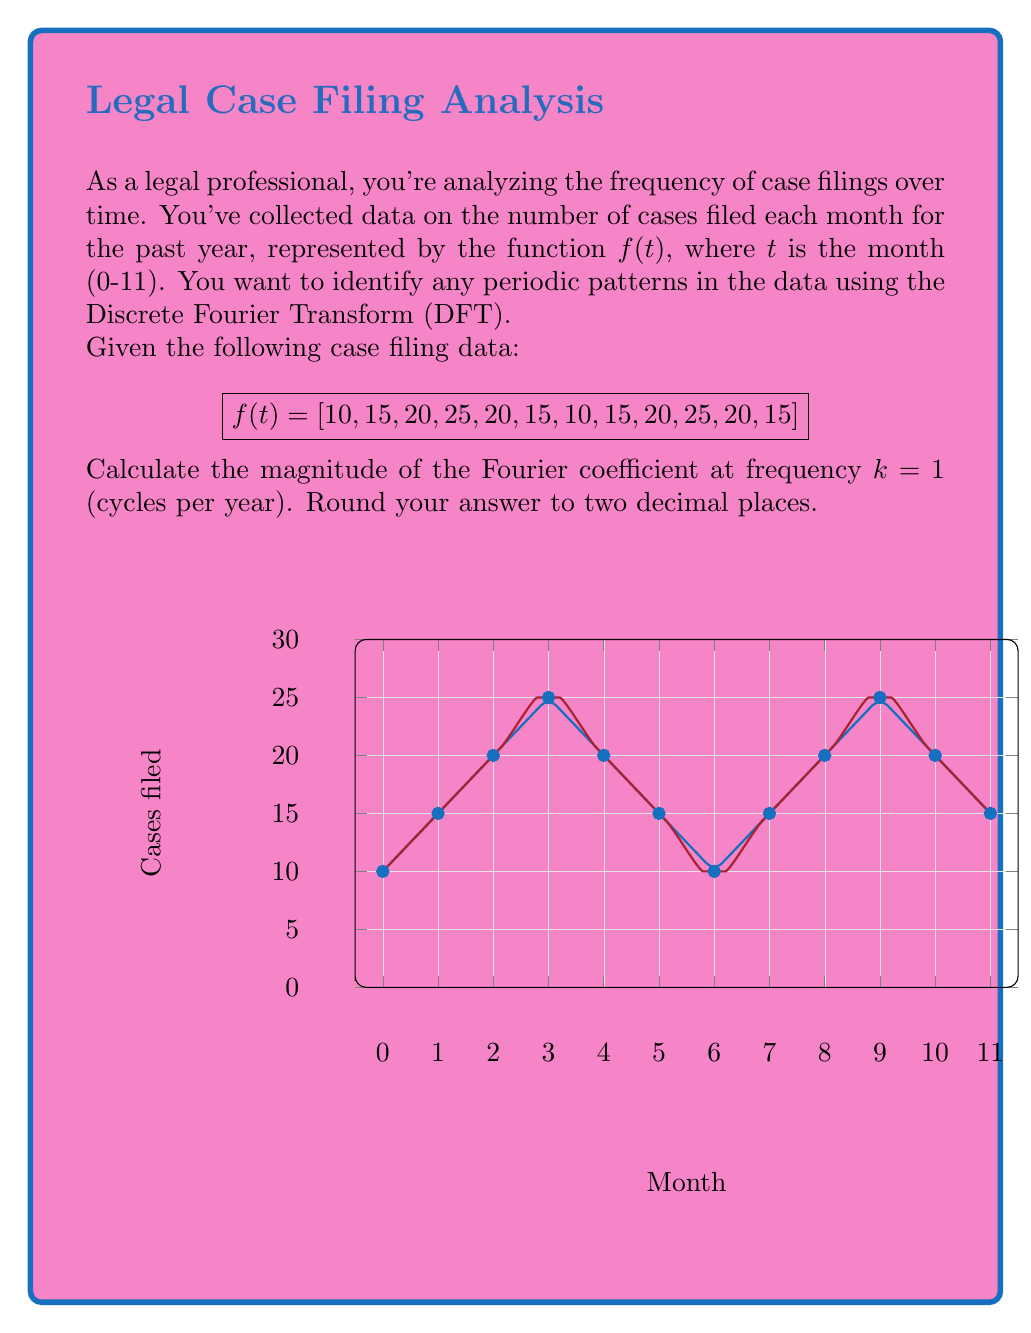Can you solve this math problem? To solve this problem, we'll follow these steps:

1) The Discrete Fourier Transform (DFT) for a sequence of N points is given by:

   $$X_k = \sum_{n=0}^{N-1} x_n e^{-i2\pi kn/N}$$

   where $X_k$ is the k-th Fourier coefficient, $x_n$ is the n-th input sample, and N is the total number of samples.

2) In this case, N = 12 (12 months of data), and we're asked to calculate for k = 1.

3) Expanding the formula for k = 1:

   $$X_1 = \sum_{n=0}^{11} f(n) e^{-i2\pi n/12}$$

4) We can separate this into real and imaginary parts:

   $$X_1 = \sum_{n=0}^{11} f(n) [\cos(2\pi n/12) - i\sin(2\pi n/12)]$$

5) Calculating the real part:
   
   $$Re(X_1) = 10\cos(0) + 15\cos(\pi/6) + 20\cos(\pi/3) + 25\cos(\pi/2) + 20\cos(2\pi/3) + 15\cos(5\pi/6) + 10\cos(\pi) + 15\cos(7\pi/6) + 20\cos(4\pi/3) + 25\cos(3\pi/2) + 20\cos(5\pi/3) + 15\cos(11\pi/6) = -15$$

6) Calculating the imaginary part:
   
   $$Im(X_1) = -[10\sin(0) + 15\sin(\pi/6) + 20\sin(\pi/3) + 25\sin(\pi/2) + 20\sin(2\pi/3) + 15\sin(5\pi/6) + 10\sin(\pi) + 15\sin(7\pi/6) + 20\sin(4\pi/3) + 25\sin(3\pi/2) + 20\sin(5\pi/3) + 15\sin(11\pi/6)] = 25.98$$

7) The magnitude of the Fourier coefficient is given by:

   $$|X_1| = \sqrt{Re(X_1)^2 + Im(X_1)^2}$$

8) Substituting the values:

   $$|X_1| = \sqrt{(-15)^2 + (25.98)^2} = 30.00$$
Answer: 30.00 